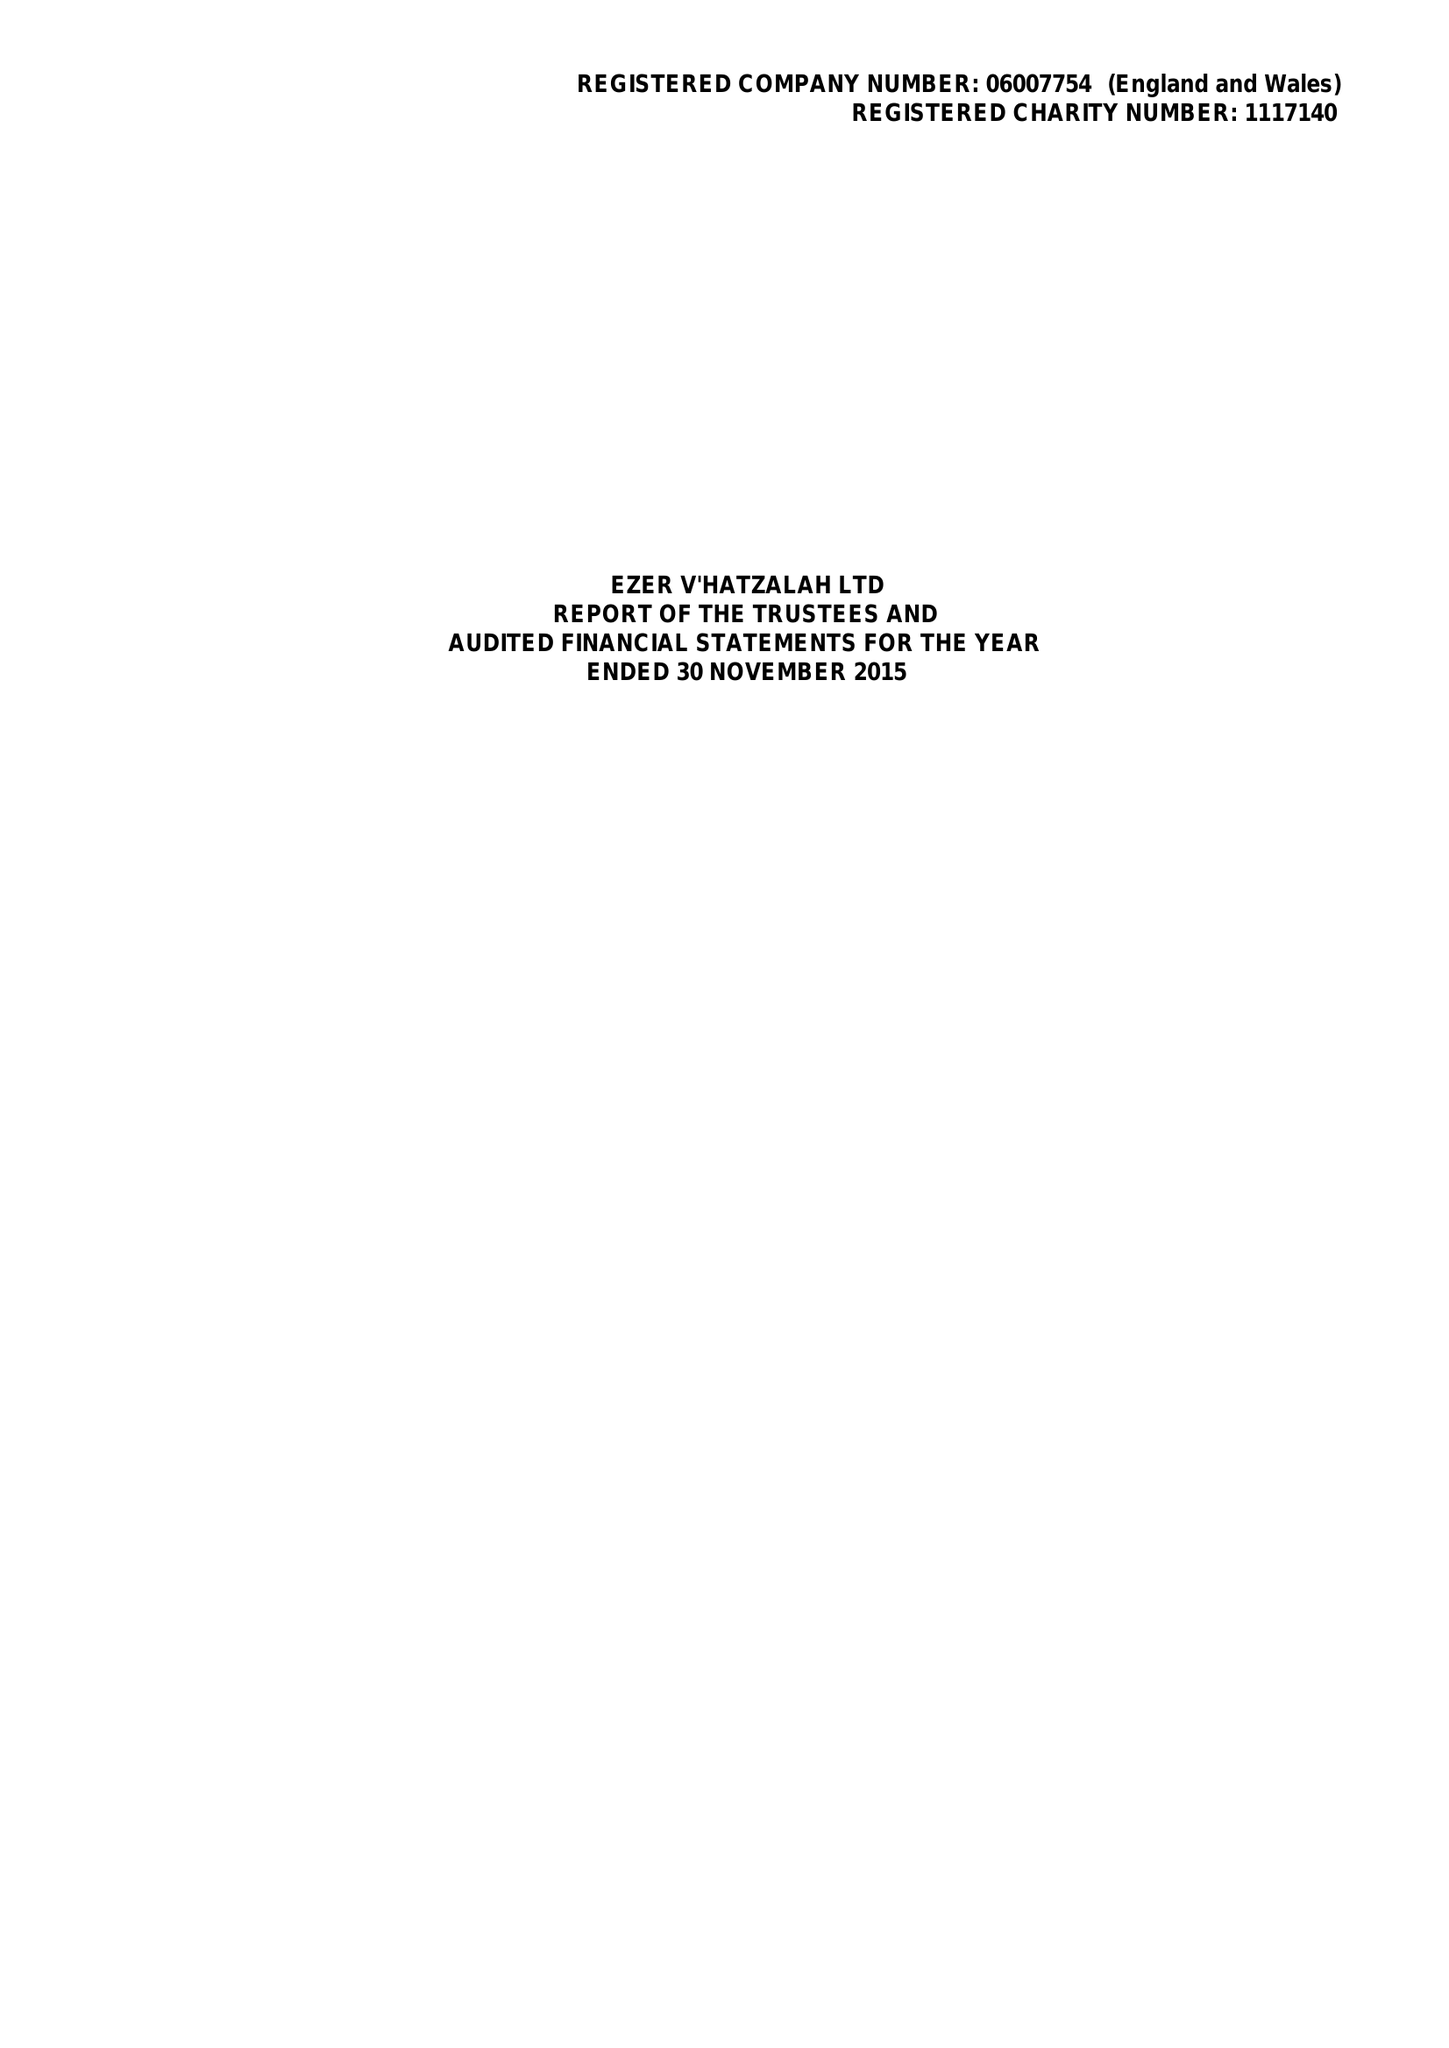What is the value for the income_annually_in_british_pounds?
Answer the question using a single word or phrase. 9559885.00 